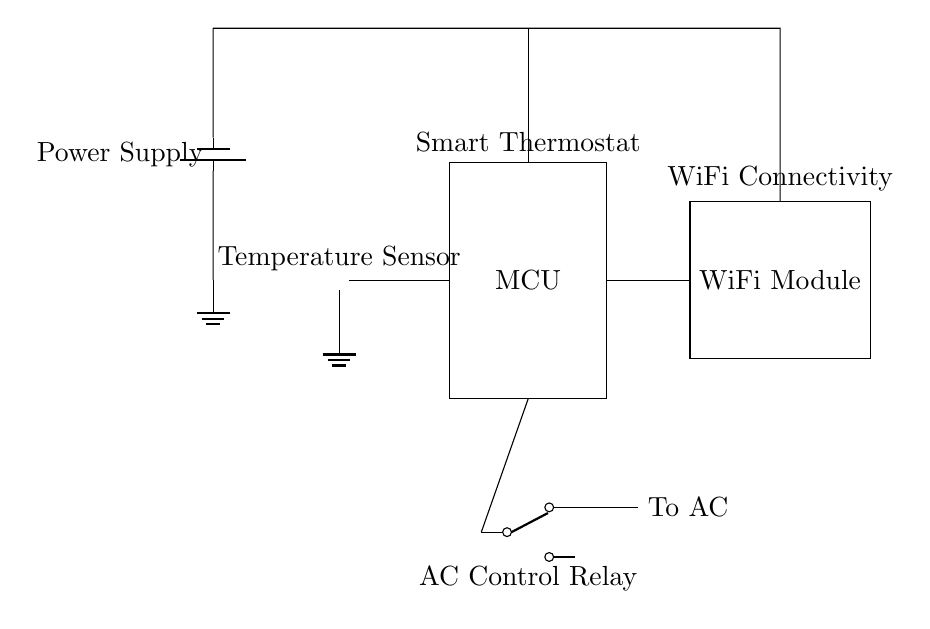What component is used to measure temperature? The circuit diagram includes a thermistor, which is the component responsible for sensing temperature. It is depicted on the left side of the diagram.
Answer: Thermistor What is the function of the WiFi module in this circuit? The WiFi module allows the smart thermostat to connect to a wireless network, enabling remote operation and control, as indicated by its position and labeling in the circuit.
Answer: WiFi connectivity How many components are connected to the microcontroller? Three components are connected to the microcontroller: the thermistor (temperature sensor), the WiFi module, and the relay for AC control, illustrated by the lines connecting them to the microcontroller.
Answer: Three What type of relay is used to control the air conditioning? The circuit uses a single-pole double-throw (SPDT) relay for controlling the air conditioning unit. This is evident from the relay's symbol and its connection to the microcontroller.
Answer: SPDT relay What is indicated by the power supply in the circuit? The power supply is represented by a battery symbol and provides the necessary voltage to the entire circuit, highlighting its importance in powering the temperature sensor, microcontroller, and WiFi module.
Answer: Battery Which component provides AC control in the circuit? The relay operates as the control mechanism for the air conditioning unit, enabling it to turn on or off based on the signals from the smart thermostat's microcontroller.
Answer: Relay 